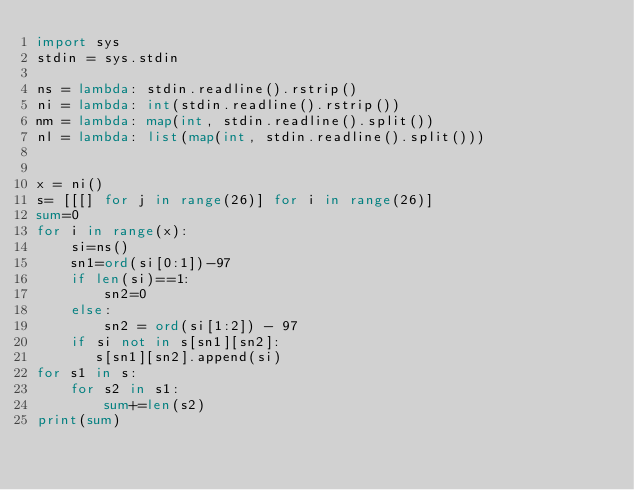Convert code to text. <code><loc_0><loc_0><loc_500><loc_500><_Python_>import sys
stdin = sys.stdin

ns = lambda: stdin.readline().rstrip()
ni = lambda: int(stdin.readline().rstrip())
nm = lambda: map(int, stdin.readline().split())
nl = lambda: list(map(int, stdin.readline().split()))


x = ni()
s= [[[] for j in range(26)] for i in range(26)]
sum=0
for i in range(x):
    si=ns()
    sn1=ord(si[0:1])-97
    if len(si)==1:
        sn2=0
    else:
        sn2 = ord(si[1:2]) - 97
    if si not in s[sn1][sn2]:
       s[sn1][sn2].append(si)
for s1 in s:
    for s2 in s1:
        sum+=len(s2)
print(sum)</code> 